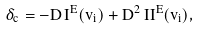Convert formula to latex. <formula><loc_0><loc_0><loc_500><loc_500>\delta _ { c } = - D \, I ^ { E } ( v _ { i } ) + D ^ { 2 } \, I I ^ { E } ( v _ { i } ) ,</formula> 